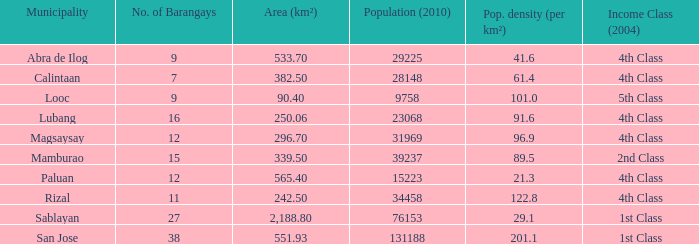Indicate the inhabitants per square kilometer in the city of abra de ilog. 41.6. Would you mind parsing the complete table? {'header': ['Municipality', 'No. of Barangays', 'Area (km²)', 'Population (2010)', 'Pop. density (per km²)', 'Income Class (2004)'], 'rows': [['Abra de Ilog', '9', '533.70', '29225', '41.6', '4th Class'], ['Calintaan', '7', '382.50', '28148', '61.4', '4th Class'], ['Looc', '9', '90.40', '9758', '101.0', '5th Class'], ['Lubang', '16', '250.06', '23068', '91.6', '4th Class'], ['Magsaysay', '12', '296.70', '31969', '96.9', '4th Class'], ['Mamburao', '15', '339.50', '39237', '89.5', '2nd Class'], ['Paluan', '12', '565.40', '15223', '21.3', '4th Class'], ['Rizal', '11', '242.50', '34458', '122.8', '4th Class'], ['Sablayan', '27', '2,188.80', '76153', '29.1', '1st Class'], ['San Jose', '38', '551.93', '131188', '201.1', '1st Class']]} 